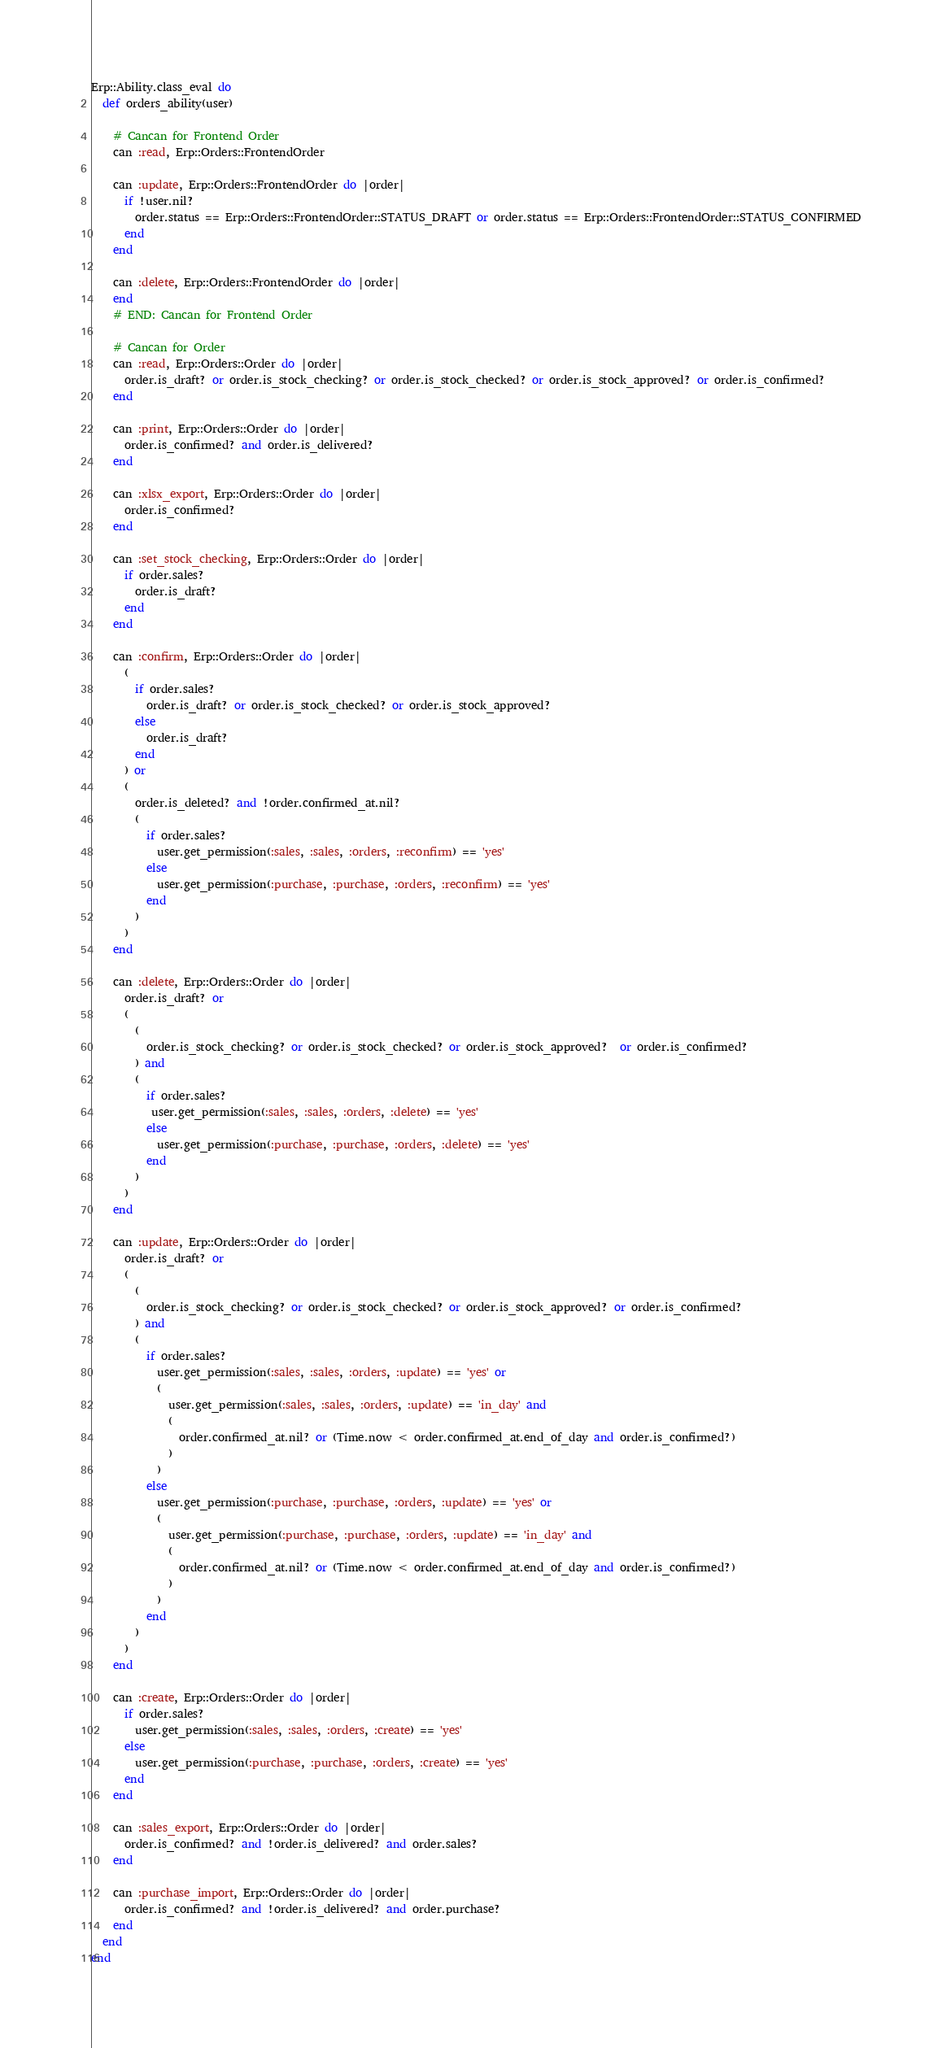<code> <loc_0><loc_0><loc_500><loc_500><_Ruby_>Erp::Ability.class_eval do
  def orders_ability(user)

    # Cancan for Frontend Order
    can :read, Erp::Orders::FrontendOrder

    can :update, Erp::Orders::FrontendOrder do |order|
      if !user.nil?
        order.status == Erp::Orders::FrontendOrder::STATUS_DRAFT or order.status == Erp::Orders::FrontendOrder::STATUS_CONFIRMED
      end
    end

    can :delete, Erp::Orders::FrontendOrder do |order|
    end
    # END: Cancan for Frontend Order

    # Cancan for Order
    can :read, Erp::Orders::Order do |order|
      order.is_draft? or order.is_stock_checking? or order.is_stock_checked? or order.is_stock_approved? or order.is_confirmed?
    end

    can :print, Erp::Orders::Order do |order|
      order.is_confirmed? and order.is_delivered?
    end

    can :xlsx_export, Erp::Orders::Order do |order|
      order.is_confirmed?
    end

    can :set_stock_checking, Erp::Orders::Order do |order|
      if order.sales?
        order.is_draft?
      end
    end

    can :confirm, Erp::Orders::Order do |order|
      (
        if order.sales?
          order.is_draft? or order.is_stock_checked? or order.is_stock_approved?
        else
          order.is_draft?
        end
      ) or
      (
        order.is_deleted? and !order.confirmed_at.nil?
        (
          if order.sales?
            user.get_permission(:sales, :sales, :orders, :reconfirm) == 'yes'
          else
            user.get_permission(:purchase, :purchase, :orders, :reconfirm) == 'yes'
          end
        )
      )
    end

    can :delete, Erp::Orders::Order do |order|
      order.is_draft? or
      (
        (
          order.is_stock_checking? or order.is_stock_checked? or order.is_stock_approved?  or order.is_confirmed?
        ) and 
        (
          if order.sales?
           user.get_permission(:sales, :sales, :orders, :delete) == 'yes'
          else
            user.get_permission(:purchase, :purchase, :orders, :delete) == 'yes'
          end
        )
      )
    end

    can :update, Erp::Orders::Order do |order|
      order.is_draft? or
      (
        (
          order.is_stock_checking? or order.is_stock_checked? or order.is_stock_approved? or order.is_confirmed?
        ) and
        (
          if order.sales?
            user.get_permission(:sales, :sales, :orders, :update) == 'yes' or
            (
              user.get_permission(:sales, :sales, :orders, :update) == 'in_day' and
              (
                order.confirmed_at.nil? or (Time.now < order.confirmed_at.end_of_day and order.is_confirmed?)
              )
            )
          else
            user.get_permission(:purchase, :purchase, :orders, :update) == 'yes' or
            (
              user.get_permission(:purchase, :purchase, :orders, :update) == 'in_day' and
              (
                order.confirmed_at.nil? or (Time.now < order.confirmed_at.end_of_day and order.is_confirmed?)
              )
            )
          end
        )
      )
    end
    
    can :create, Erp::Orders::Order do |order|
      if order.sales?
        user.get_permission(:sales, :sales, :orders, :create) == 'yes'
      else
        user.get_permission(:purchase, :purchase, :orders, :create) == 'yes'
      end
    end

    can :sales_export, Erp::Orders::Order do |order|
      order.is_confirmed? and !order.is_delivered? and order.sales?
    end

    can :purchase_import, Erp::Orders::Order do |order|
      order.is_confirmed? and !order.is_delivered? and order.purchase?
    end
  end
end
</code> 